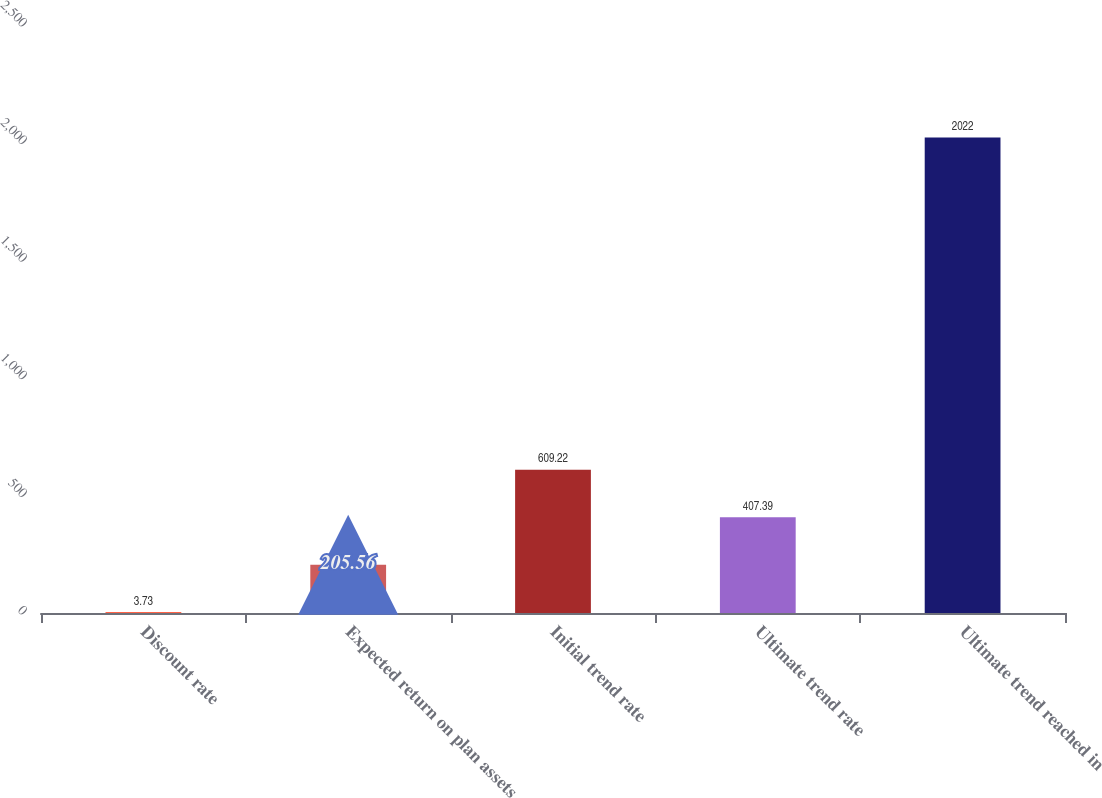Convert chart. <chart><loc_0><loc_0><loc_500><loc_500><bar_chart><fcel>Discount rate<fcel>Expected return on plan assets<fcel>Initial trend rate<fcel>Ultimate trend rate<fcel>Ultimate trend reached in<nl><fcel>3.73<fcel>205.56<fcel>609.22<fcel>407.39<fcel>2022<nl></chart> 